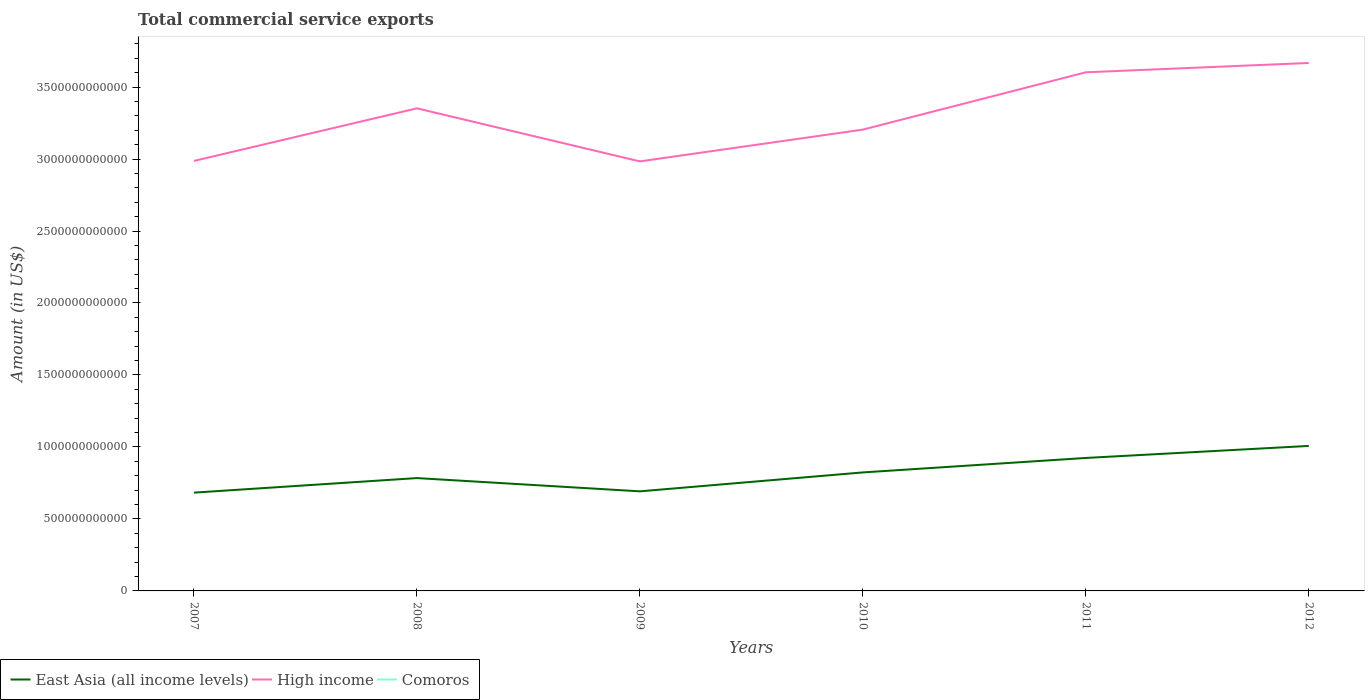Across all years, what is the maximum total commercial service exports in High income?
Your answer should be compact. 2.98e+12. What is the total total commercial service exports in High income in the graph?
Ensure brevity in your answer.  -3.15e+11. What is the difference between the highest and the second highest total commercial service exports in Comoros?
Provide a short and direct response. 1.30e+07. What is the difference between the highest and the lowest total commercial service exports in East Asia (all income levels)?
Provide a succinct answer. 3. Is the total commercial service exports in High income strictly greater than the total commercial service exports in East Asia (all income levels) over the years?
Give a very brief answer. No. How many lines are there?
Keep it short and to the point. 3. What is the difference between two consecutive major ticks on the Y-axis?
Ensure brevity in your answer.  5.00e+11. Are the values on the major ticks of Y-axis written in scientific E-notation?
Your answer should be compact. No. Does the graph contain grids?
Provide a succinct answer. No. Where does the legend appear in the graph?
Offer a terse response. Bottom left. How many legend labels are there?
Offer a very short reply. 3. What is the title of the graph?
Your answer should be very brief. Total commercial service exports. Does "Serbia" appear as one of the legend labels in the graph?
Your answer should be very brief. No. What is the label or title of the Y-axis?
Keep it short and to the point. Amount (in US$). What is the Amount (in US$) in East Asia (all income levels) in 2007?
Give a very brief answer. 6.83e+11. What is the Amount (in US$) in High income in 2007?
Give a very brief answer. 2.99e+12. What is the Amount (in US$) in Comoros in 2007?
Offer a terse response. 5.05e+07. What is the Amount (in US$) in East Asia (all income levels) in 2008?
Your answer should be very brief. 7.84e+11. What is the Amount (in US$) of High income in 2008?
Your answer should be compact. 3.35e+12. What is the Amount (in US$) of Comoros in 2008?
Ensure brevity in your answer.  5.62e+07. What is the Amount (in US$) of East Asia (all income levels) in 2009?
Offer a very short reply. 6.92e+11. What is the Amount (in US$) of High income in 2009?
Ensure brevity in your answer.  2.98e+12. What is the Amount (in US$) in Comoros in 2009?
Keep it short and to the point. 5.05e+07. What is the Amount (in US$) of East Asia (all income levels) in 2010?
Offer a terse response. 8.23e+11. What is the Amount (in US$) in High income in 2010?
Offer a very short reply. 3.20e+12. What is the Amount (in US$) of Comoros in 2010?
Provide a succinct answer. 5.54e+07. What is the Amount (in US$) of East Asia (all income levels) in 2011?
Provide a short and direct response. 9.24e+11. What is the Amount (in US$) of High income in 2011?
Ensure brevity in your answer.  3.60e+12. What is the Amount (in US$) of Comoros in 2011?
Ensure brevity in your answer.  6.35e+07. What is the Amount (in US$) of East Asia (all income levels) in 2012?
Provide a succinct answer. 1.01e+12. What is the Amount (in US$) of High income in 2012?
Your response must be concise. 3.67e+12. What is the Amount (in US$) in Comoros in 2012?
Your response must be concise. 6.09e+07. Across all years, what is the maximum Amount (in US$) in East Asia (all income levels)?
Your answer should be very brief. 1.01e+12. Across all years, what is the maximum Amount (in US$) in High income?
Keep it short and to the point. 3.67e+12. Across all years, what is the maximum Amount (in US$) in Comoros?
Give a very brief answer. 6.35e+07. Across all years, what is the minimum Amount (in US$) in East Asia (all income levels)?
Make the answer very short. 6.83e+11. Across all years, what is the minimum Amount (in US$) in High income?
Give a very brief answer. 2.98e+12. Across all years, what is the minimum Amount (in US$) in Comoros?
Your response must be concise. 5.05e+07. What is the total Amount (in US$) in East Asia (all income levels) in the graph?
Offer a very short reply. 4.91e+12. What is the total Amount (in US$) of High income in the graph?
Make the answer very short. 1.98e+13. What is the total Amount (in US$) in Comoros in the graph?
Provide a succinct answer. 3.37e+08. What is the difference between the Amount (in US$) in East Asia (all income levels) in 2007 and that in 2008?
Provide a succinct answer. -1.01e+11. What is the difference between the Amount (in US$) in High income in 2007 and that in 2008?
Your response must be concise. -3.65e+11. What is the difference between the Amount (in US$) of Comoros in 2007 and that in 2008?
Provide a short and direct response. -5.61e+06. What is the difference between the Amount (in US$) in East Asia (all income levels) in 2007 and that in 2009?
Your answer should be very brief. -8.98e+09. What is the difference between the Amount (in US$) in High income in 2007 and that in 2009?
Provide a succinct answer. 3.19e+09. What is the difference between the Amount (in US$) of Comoros in 2007 and that in 2009?
Provide a succinct answer. 9956.03. What is the difference between the Amount (in US$) in East Asia (all income levels) in 2007 and that in 2010?
Your answer should be very brief. -1.40e+11. What is the difference between the Amount (in US$) of High income in 2007 and that in 2010?
Keep it short and to the point. -2.17e+11. What is the difference between the Amount (in US$) in Comoros in 2007 and that in 2010?
Make the answer very short. -4.85e+06. What is the difference between the Amount (in US$) in East Asia (all income levels) in 2007 and that in 2011?
Your answer should be compact. -2.41e+11. What is the difference between the Amount (in US$) in High income in 2007 and that in 2011?
Your answer should be very brief. -6.16e+11. What is the difference between the Amount (in US$) in Comoros in 2007 and that in 2011?
Make the answer very short. -1.30e+07. What is the difference between the Amount (in US$) in East Asia (all income levels) in 2007 and that in 2012?
Provide a short and direct response. -3.24e+11. What is the difference between the Amount (in US$) in High income in 2007 and that in 2012?
Your answer should be very brief. -6.80e+11. What is the difference between the Amount (in US$) in Comoros in 2007 and that in 2012?
Your response must be concise. -1.04e+07. What is the difference between the Amount (in US$) of East Asia (all income levels) in 2008 and that in 2009?
Offer a very short reply. 9.21e+1. What is the difference between the Amount (in US$) of High income in 2008 and that in 2009?
Your response must be concise. 3.69e+11. What is the difference between the Amount (in US$) of Comoros in 2008 and that in 2009?
Provide a succinct answer. 5.62e+06. What is the difference between the Amount (in US$) of East Asia (all income levels) in 2008 and that in 2010?
Ensure brevity in your answer.  -3.93e+1. What is the difference between the Amount (in US$) in High income in 2008 and that in 2010?
Your answer should be very brief. 1.48e+11. What is the difference between the Amount (in US$) of Comoros in 2008 and that in 2010?
Give a very brief answer. 7.63e+05. What is the difference between the Amount (in US$) in East Asia (all income levels) in 2008 and that in 2011?
Offer a terse response. -1.40e+11. What is the difference between the Amount (in US$) in High income in 2008 and that in 2011?
Ensure brevity in your answer.  -2.50e+11. What is the difference between the Amount (in US$) in Comoros in 2008 and that in 2011?
Keep it short and to the point. -7.37e+06. What is the difference between the Amount (in US$) of East Asia (all income levels) in 2008 and that in 2012?
Your answer should be very brief. -2.23e+11. What is the difference between the Amount (in US$) of High income in 2008 and that in 2012?
Provide a short and direct response. -3.15e+11. What is the difference between the Amount (in US$) of Comoros in 2008 and that in 2012?
Offer a terse response. -4.77e+06. What is the difference between the Amount (in US$) of East Asia (all income levels) in 2009 and that in 2010?
Your response must be concise. -1.31e+11. What is the difference between the Amount (in US$) of High income in 2009 and that in 2010?
Provide a succinct answer. -2.21e+11. What is the difference between the Amount (in US$) of Comoros in 2009 and that in 2010?
Your answer should be compact. -4.86e+06. What is the difference between the Amount (in US$) in East Asia (all income levels) in 2009 and that in 2011?
Your response must be concise. -2.32e+11. What is the difference between the Amount (in US$) of High income in 2009 and that in 2011?
Give a very brief answer. -6.19e+11. What is the difference between the Amount (in US$) of Comoros in 2009 and that in 2011?
Make the answer very short. -1.30e+07. What is the difference between the Amount (in US$) in East Asia (all income levels) in 2009 and that in 2012?
Provide a succinct answer. -3.15e+11. What is the difference between the Amount (in US$) of High income in 2009 and that in 2012?
Ensure brevity in your answer.  -6.84e+11. What is the difference between the Amount (in US$) of Comoros in 2009 and that in 2012?
Make the answer very short. -1.04e+07. What is the difference between the Amount (in US$) in East Asia (all income levels) in 2010 and that in 2011?
Your answer should be compact. -1.01e+11. What is the difference between the Amount (in US$) in High income in 2010 and that in 2011?
Ensure brevity in your answer.  -3.98e+11. What is the difference between the Amount (in US$) of Comoros in 2010 and that in 2011?
Offer a terse response. -8.13e+06. What is the difference between the Amount (in US$) of East Asia (all income levels) in 2010 and that in 2012?
Provide a succinct answer. -1.84e+11. What is the difference between the Amount (in US$) in High income in 2010 and that in 2012?
Provide a succinct answer. -4.63e+11. What is the difference between the Amount (in US$) of Comoros in 2010 and that in 2012?
Provide a succinct answer. -5.54e+06. What is the difference between the Amount (in US$) of East Asia (all income levels) in 2011 and that in 2012?
Give a very brief answer. -8.36e+1. What is the difference between the Amount (in US$) in High income in 2011 and that in 2012?
Provide a succinct answer. -6.48e+1. What is the difference between the Amount (in US$) in Comoros in 2011 and that in 2012?
Your response must be concise. 2.60e+06. What is the difference between the Amount (in US$) in East Asia (all income levels) in 2007 and the Amount (in US$) in High income in 2008?
Provide a succinct answer. -2.67e+12. What is the difference between the Amount (in US$) in East Asia (all income levels) in 2007 and the Amount (in US$) in Comoros in 2008?
Your response must be concise. 6.83e+11. What is the difference between the Amount (in US$) of High income in 2007 and the Amount (in US$) of Comoros in 2008?
Provide a succinct answer. 2.99e+12. What is the difference between the Amount (in US$) of East Asia (all income levels) in 2007 and the Amount (in US$) of High income in 2009?
Ensure brevity in your answer.  -2.30e+12. What is the difference between the Amount (in US$) in East Asia (all income levels) in 2007 and the Amount (in US$) in Comoros in 2009?
Offer a terse response. 6.83e+11. What is the difference between the Amount (in US$) of High income in 2007 and the Amount (in US$) of Comoros in 2009?
Make the answer very short. 2.99e+12. What is the difference between the Amount (in US$) in East Asia (all income levels) in 2007 and the Amount (in US$) in High income in 2010?
Ensure brevity in your answer.  -2.52e+12. What is the difference between the Amount (in US$) of East Asia (all income levels) in 2007 and the Amount (in US$) of Comoros in 2010?
Ensure brevity in your answer.  6.83e+11. What is the difference between the Amount (in US$) of High income in 2007 and the Amount (in US$) of Comoros in 2010?
Give a very brief answer. 2.99e+12. What is the difference between the Amount (in US$) in East Asia (all income levels) in 2007 and the Amount (in US$) in High income in 2011?
Ensure brevity in your answer.  -2.92e+12. What is the difference between the Amount (in US$) in East Asia (all income levels) in 2007 and the Amount (in US$) in Comoros in 2011?
Keep it short and to the point. 6.83e+11. What is the difference between the Amount (in US$) in High income in 2007 and the Amount (in US$) in Comoros in 2011?
Your answer should be compact. 2.99e+12. What is the difference between the Amount (in US$) of East Asia (all income levels) in 2007 and the Amount (in US$) of High income in 2012?
Give a very brief answer. -2.98e+12. What is the difference between the Amount (in US$) in East Asia (all income levels) in 2007 and the Amount (in US$) in Comoros in 2012?
Offer a very short reply. 6.83e+11. What is the difference between the Amount (in US$) in High income in 2007 and the Amount (in US$) in Comoros in 2012?
Your response must be concise. 2.99e+12. What is the difference between the Amount (in US$) in East Asia (all income levels) in 2008 and the Amount (in US$) in High income in 2009?
Ensure brevity in your answer.  -2.20e+12. What is the difference between the Amount (in US$) of East Asia (all income levels) in 2008 and the Amount (in US$) of Comoros in 2009?
Keep it short and to the point. 7.84e+11. What is the difference between the Amount (in US$) of High income in 2008 and the Amount (in US$) of Comoros in 2009?
Give a very brief answer. 3.35e+12. What is the difference between the Amount (in US$) of East Asia (all income levels) in 2008 and the Amount (in US$) of High income in 2010?
Provide a short and direct response. -2.42e+12. What is the difference between the Amount (in US$) in East Asia (all income levels) in 2008 and the Amount (in US$) in Comoros in 2010?
Keep it short and to the point. 7.84e+11. What is the difference between the Amount (in US$) in High income in 2008 and the Amount (in US$) in Comoros in 2010?
Provide a short and direct response. 3.35e+12. What is the difference between the Amount (in US$) in East Asia (all income levels) in 2008 and the Amount (in US$) in High income in 2011?
Make the answer very short. -2.82e+12. What is the difference between the Amount (in US$) of East Asia (all income levels) in 2008 and the Amount (in US$) of Comoros in 2011?
Your answer should be compact. 7.84e+11. What is the difference between the Amount (in US$) in High income in 2008 and the Amount (in US$) in Comoros in 2011?
Make the answer very short. 3.35e+12. What is the difference between the Amount (in US$) in East Asia (all income levels) in 2008 and the Amount (in US$) in High income in 2012?
Ensure brevity in your answer.  -2.88e+12. What is the difference between the Amount (in US$) of East Asia (all income levels) in 2008 and the Amount (in US$) of Comoros in 2012?
Make the answer very short. 7.84e+11. What is the difference between the Amount (in US$) of High income in 2008 and the Amount (in US$) of Comoros in 2012?
Your answer should be compact. 3.35e+12. What is the difference between the Amount (in US$) of East Asia (all income levels) in 2009 and the Amount (in US$) of High income in 2010?
Give a very brief answer. -2.51e+12. What is the difference between the Amount (in US$) in East Asia (all income levels) in 2009 and the Amount (in US$) in Comoros in 2010?
Give a very brief answer. 6.92e+11. What is the difference between the Amount (in US$) in High income in 2009 and the Amount (in US$) in Comoros in 2010?
Make the answer very short. 2.98e+12. What is the difference between the Amount (in US$) in East Asia (all income levels) in 2009 and the Amount (in US$) in High income in 2011?
Offer a terse response. -2.91e+12. What is the difference between the Amount (in US$) in East Asia (all income levels) in 2009 and the Amount (in US$) in Comoros in 2011?
Make the answer very short. 6.92e+11. What is the difference between the Amount (in US$) of High income in 2009 and the Amount (in US$) of Comoros in 2011?
Give a very brief answer. 2.98e+12. What is the difference between the Amount (in US$) in East Asia (all income levels) in 2009 and the Amount (in US$) in High income in 2012?
Your answer should be very brief. -2.98e+12. What is the difference between the Amount (in US$) of East Asia (all income levels) in 2009 and the Amount (in US$) of Comoros in 2012?
Give a very brief answer. 6.92e+11. What is the difference between the Amount (in US$) in High income in 2009 and the Amount (in US$) in Comoros in 2012?
Ensure brevity in your answer.  2.98e+12. What is the difference between the Amount (in US$) in East Asia (all income levels) in 2010 and the Amount (in US$) in High income in 2011?
Offer a terse response. -2.78e+12. What is the difference between the Amount (in US$) in East Asia (all income levels) in 2010 and the Amount (in US$) in Comoros in 2011?
Your response must be concise. 8.23e+11. What is the difference between the Amount (in US$) in High income in 2010 and the Amount (in US$) in Comoros in 2011?
Ensure brevity in your answer.  3.20e+12. What is the difference between the Amount (in US$) of East Asia (all income levels) in 2010 and the Amount (in US$) of High income in 2012?
Your answer should be very brief. -2.84e+12. What is the difference between the Amount (in US$) in East Asia (all income levels) in 2010 and the Amount (in US$) in Comoros in 2012?
Ensure brevity in your answer.  8.23e+11. What is the difference between the Amount (in US$) in High income in 2010 and the Amount (in US$) in Comoros in 2012?
Provide a succinct answer. 3.20e+12. What is the difference between the Amount (in US$) of East Asia (all income levels) in 2011 and the Amount (in US$) of High income in 2012?
Ensure brevity in your answer.  -2.74e+12. What is the difference between the Amount (in US$) of East Asia (all income levels) in 2011 and the Amount (in US$) of Comoros in 2012?
Make the answer very short. 9.24e+11. What is the difference between the Amount (in US$) of High income in 2011 and the Amount (in US$) of Comoros in 2012?
Offer a very short reply. 3.60e+12. What is the average Amount (in US$) in East Asia (all income levels) per year?
Give a very brief answer. 8.19e+11. What is the average Amount (in US$) in High income per year?
Ensure brevity in your answer.  3.30e+12. What is the average Amount (in US$) of Comoros per year?
Your response must be concise. 5.62e+07. In the year 2007, what is the difference between the Amount (in US$) of East Asia (all income levels) and Amount (in US$) of High income?
Provide a succinct answer. -2.30e+12. In the year 2007, what is the difference between the Amount (in US$) of East Asia (all income levels) and Amount (in US$) of Comoros?
Provide a short and direct response. 6.83e+11. In the year 2007, what is the difference between the Amount (in US$) in High income and Amount (in US$) in Comoros?
Your answer should be very brief. 2.99e+12. In the year 2008, what is the difference between the Amount (in US$) in East Asia (all income levels) and Amount (in US$) in High income?
Provide a succinct answer. -2.57e+12. In the year 2008, what is the difference between the Amount (in US$) in East Asia (all income levels) and Amount (in US$) in Comoros?
Ensure brevity in your answer.  7.84e+11. In the year 2008, what is the difference between the Amount (in US$) of High income and Amount (in US$) of Comoros?
Provide a succinct answer. 3.35e+12. In the year 2009, what is the difference between the Amount (in US$) in East Asia (all income levels) and Amount (in US$) in High income?
Offer a terse response. -2.29e+12. In the year 2009, what is the difference between the Amount (in US$) of East Asia (all income levels) and Amount (in US$) of Comoros?
Provide a succinct answer. 6.92e+11. In the year 2009, what is the difference between the Amount (in US$) of High income and Amount (in US$) of Comoros?
Your response must be concise. 2.98e+12. In the year 2010, what is the difference between the Amount (in US$) in East Asia (all income levels) and Amount (in US$) in High income?
Provide a short and direct response. -2.38e+12. In the year 2010, what is the difference between the Amount (in US$) in East Asia (all income levels) and Amount (in US$) in Comoros?
Make the answer very short. 8.23e+11. In the year 2010, what is the difference between the Amount (in US$) in High income and Amount (in US$) in Comoros?
Make the answer very short. 3.20e+12. In the year 2011, what is the difference between the Amount (in US$) in East Asia (all income levels) and Amount (in US$) in High income?
Make the answer very short. -2.68e+12. In the year 2011, what is the difference between the Amount (in US$) in East Asia (all income levels) and Amount (in US$) in Comoros?
Ensure brevity in your answer.  9.24e+11. In the year 2011, what is the difference between the Amount (in US$) in High income and Amount (in US$) in Comoros?
Ensure brevity in your answer.  3.60e+12. In the year 2012, what is the difference between the Amount (in US$) in East Asia (all income levels) and Amount (in US$) in High income?
Offer a very short reply. -2.66e+12. In the year 2012, what is the difference between the Amount (in US$) in East Asia (all income levels) and Amount (in US$) in Comoros?
Your answer should be very brief. 1.01e+12. In the year 2012, what is the difference between the Amount (in US$) in High income and Amount (in US$) in Comoros?
Make the answer very short. 3.67e+12. What is the ratio of the Amount (in US$) of East Asia (all income levels) in 2007 to that in 2008?
Make the answer very short. 0.87. What is the ratio of the Amount (in US$) of High income in 2007 to that in 2008?
Make the answer very short. 0.89. What is the ratio of the Amount (in US$) of Comoros in 2007 to that in 2008?
Offer a very short reply. 0.9. What is the ratio of the Amount (in US$) of East Asia (all income levels) in 2007 to that in 2009?
Provide a succinct answer. 0.99. What is the ratio of the Amount (in US$) of Comoros in 2007 to that in 2009?
Your answer should be very brief. 1. What is the ratio of the Amount (in US$) in East Asia (all income levels) in 2007 to that in 2010?
Keep it short and to the point. 0.83. What is the ratio of the Amount (in US$) of High income in 2007 to that in 2010?
Offer a very short reply. 0.93. What is the ratio of the Amount (in US$) of Comoros in 2007 to that in 2010?
Ensure brevity in your answer.  0.91. What is the ratio of the Amount (in US$) of East Asia (all income levels) in 2007 to that in 2011?
Provide a succinct answer. 0.74. What is the ratio of the Amount (in US$) in High income in 2007 to that in 2011?
Your answer should be very brief. 0.83. What is the ratio of the Amount (in US$) in Comoros in 2007 to that in 2011?
Provide a succinct answer. 0.8. What is the ratio of the Amount (in US$) of East Asia (all income levels) in 2007 to that in 2012?
Provide a short and direct response. 0.68. What is the ratio of the Amount (in US$) in High income in 2007 to that in 2012?
Offer a terse response. 0.81. What is the ratio of the Amount (in US$) of Comoros in 2007 to that in 2012?
Give a very brief answer. 0.83. What is the ratio of the Amount (in US$) of East Asia (all income levels) in 2008 to that in 2009?
Give a very brief answer. 1.13. What is the ratio of the Amount (in US$) in High income in 2008 to that in 2009?
Offer a terse response. 1.12. What is the ratio of the Amount (in US$) in Comoros in 2008 to that in 2009?
Your response must be concise. 1.11. What is the ratio of the Amount (in US$) in East Asia (all income levels) in 2008 to that in 2010?
Offer a very short reply. 0.95. What is the ratio of the Amount (in US$) in High income in 2008 to that in 2010?
Provide a succinct answer. 1.05. What is the ratio of the Amount (in US$) in Comoros in 2008 to that in 2010?
Offer a very short reply. 1.01. What is the ratio of the Amount (in US$) in East Asia (all income levels) in 2008 to that in 2011?
Your response must be concise. 0.85. What is the ratio of the Amount (in US$) of High income in 2008 to that in 2011?
Make the answer very short. 0.93. What is the ratio of the Amount (in US$) in Comoros in 2008 to that in 2011?
Make the answer very short. 0.88. What is the ratio of the Amount (in US$) in East Asia (all income levels) in 2008 to that in 2012?
Keep it short and to the point. 0.78. What is the ratio of the Amount (in US$) of High income in 2008 to that in 2012?
Make the answer very short. 0.91. What is the ratio of the Amount (in US$) in Comoros in 2008 to that in 2012?
Offer a very short reply. 0.92. What is the ratio of the Amount (in US$) of East Asia (all income levels) in 2009 to that in 2010?
Give a very brief answer. 0.84. What is the ratio of the Amount (in US$) in High income in 2009 to that in 2010?
Provide a succinct answer. 0.93. What is the ratio of the Amount (in US$) in Comoros in 2009 to that in 2010?
Offer a very short reply. 0.91. What is the ratio of the Amount (in US$) of East Asia (all income levels) in 2009 to that in 2011?
Offer a terse response. 0.75. What is the ratio of the Amount (in US$) in High income in 2009 to that in 2011?
Offer a very short reply. 0.83. What is the ratio of the Amount (in US$) of Comoros in 2009 to that in 2011?
Your response must be concise. 0.8. What is the ratio of the Amount (in US$) in East Asia (all income levels) in 2009 to that in 2012?
Make the answer very short. 0.69. What is the ratio of the Amount (in US$) of High income in 2009 to that in 2012?
Offer a terse response. 0.81. What is the ratio of the Amount (in US$) in Comoros in 2009 to that in 2012?
Offer a very short reply. 0.83. What is the ratio of the Amount (in US$) in East Asia (all income levels) in 2010 to that in 2011?
Offer a terse response. 0.89. What is the ratio of the Amount (in US$) in High income in 2010 to that in 2011?
Your answer should be compact. 0.89. What is the ratio of the Amount (in US$) in Comoros in 2010 to that in 2011?
Your response must be concise. 0.87. What is the ratio of the Amount (in US$) of East Asia (all income levels) in 2010 to that in 2012?
Your answer should be very brief. 0.82. What is the ratio of the Amount (in US$) in High income in 2010 to that in 2012?
Your answer should be compact. 0.87. What is the ratio of the Amount (in US$) of East Asia (all income levels) in 2011 to that in 2012?
Provide a succinct answer. 0.92. What is the ratio of the Amount (in US$) of High income in 2011 to that in 2012?
Give a very brief answer. 0.98. What is the ratio of the Amount (in US$) in Comoros in 2011 to that in 2012?
Your response must be concise. 1.04. What is the difference between the highest and the second highest Amount (in US$) of East Asia (all income levels)?
Give a very brief answer. 8.36e+1. What is the difference between the highest and the second highest Amount (in US$) of High income?
Provide a short and direct response. 6.48e+1. What is the difference between the highest and the second highest Amount (in US$) of Comoros?
Your answer should be compact. 2.60e+06. What is the difference between the highest and the lowest Amount (in US$) in East Asia (all income levels)?
Provide a short and direct response. 3.24e+11. What is the difference between the highest and the lowest Amount (in US$) in High income?
Offer a terse response. 6.84e+11. What is the difference between the highest and the lowest Amount (in US$) in Comoros?
Your answer should be compact. 1.30e+07. 